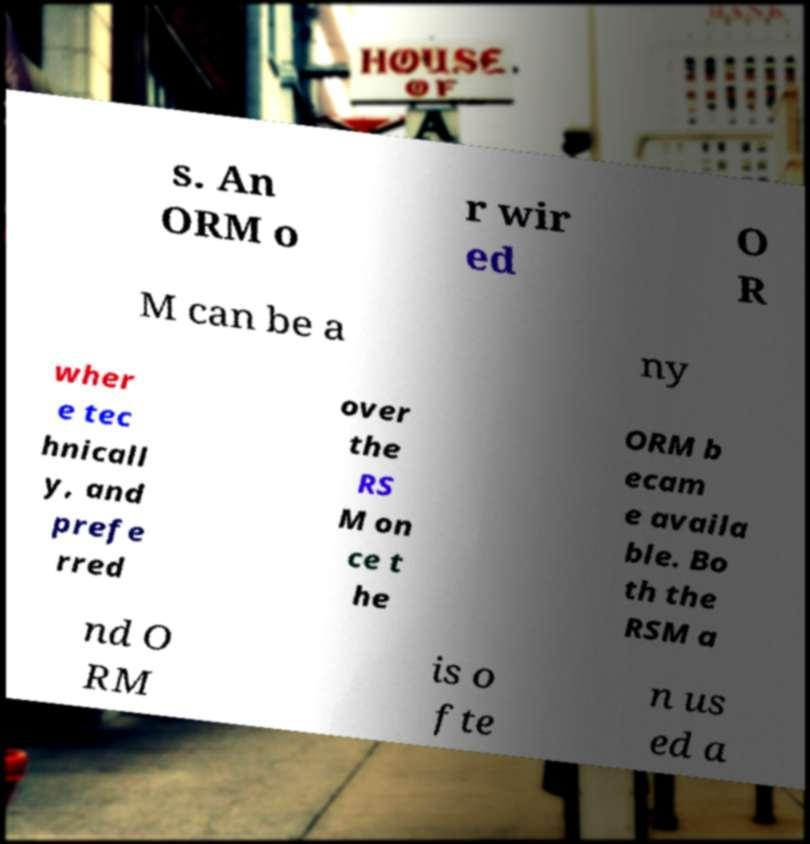Please identify and transcribe the text found in this image. s. An ORM o r wir ed O R M can be a ny wher e tec hnicall y, and prefe rred over the RS M on ce t he ORM b ecam e availa ble. Bo th the RSM a nd O RM is o fte n us ed a 